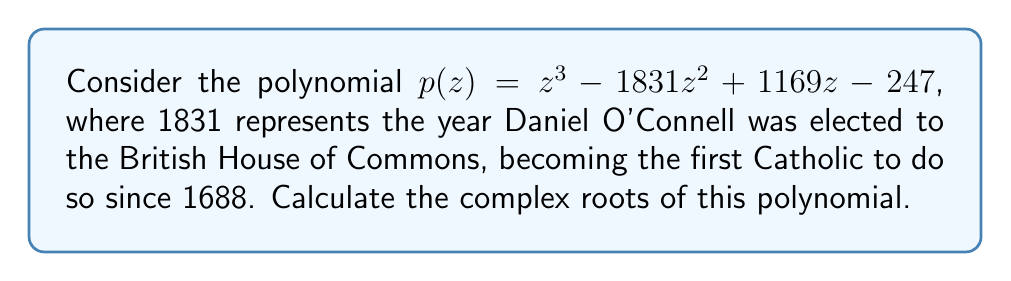What is the answer to this math problem? To find the complex roots of this polynomial, we'll follow these steps:

1) First, we need to factor the polynomial. The constant term -247 suggests that one of the roots might be related to this number. Indeed, we can verify that 13 is a root:

   $p(13) = 13^3 - 1831 \cdot 13^2 + 1169 \cdot 13 - 247 = 0$

2) Now we can factor out $(z-13)$:

   $p(z) = (z-13)(z^2 - 1818z + 19)$

3) We now need to solve the quadratic equation $z^2 - 1818z + 19 = 0$

4) We can use the quadratic formula: $z = \frac{-b \pm \sqrt{b^2 - 4ac}}{2a}$

   Where $a=1$, $b=-1818$, and $c=19$

5) Calculating:

   $z = \frac{1818 \pm \sqrt{1818^2 - 4(1)(19)}}{2(1)}$

   $z = \frac{1818 \pm \sqrt{3305124 - 76}}{2}$

   $z = \frac{1818 \pm \sqrt{3305048}}{2}$

   $z = \frac{1818 \pm 1818}{2}$

6) This gives us two more roots:

   $z = \frac{1818 + 1818}{2} = 1818$

   $z = \frac{1818 - 1818}{2} = 0$

Therefore, the three roots of the polynomial are 13, 1818, and 0.
Answer: The complex roots of the polynomial $p(z) = z^3 - 1831z^2 + 1169z - 247$ are $13$, $1818$, and $0$. 